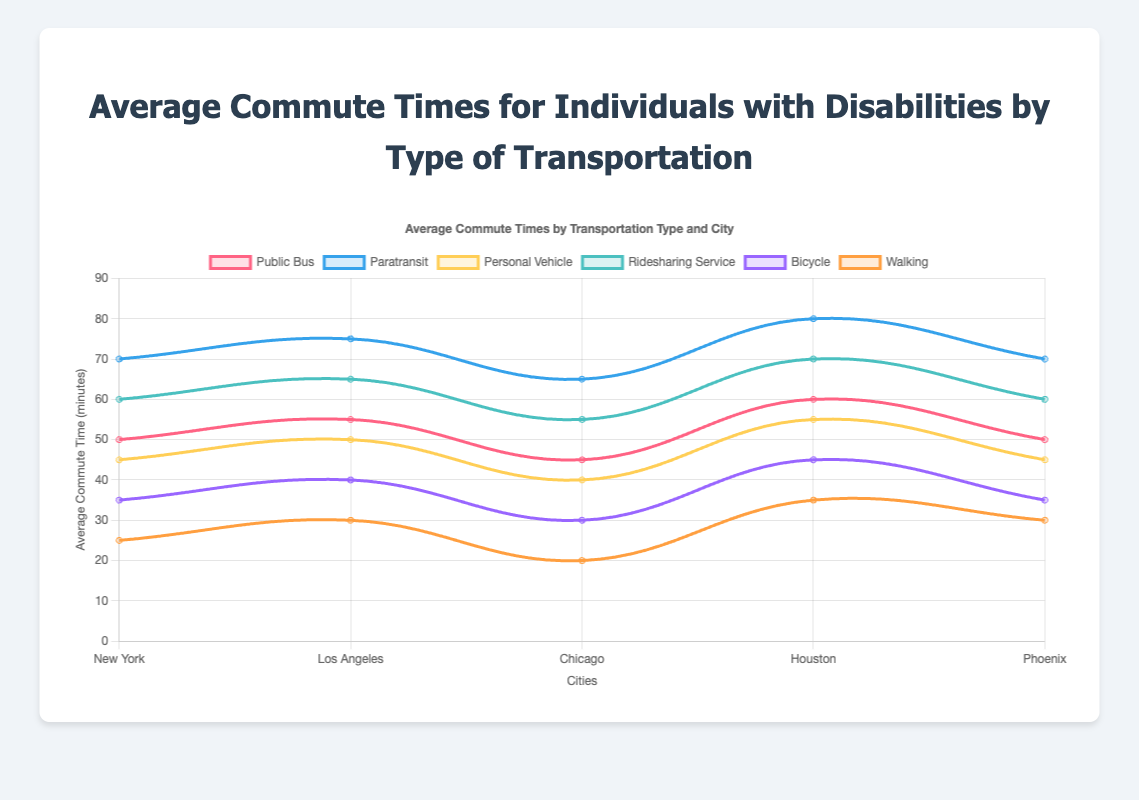What is the average commute time using a Public Bus in Chicago? The plot shows the average commute time for individuals with disabilities using various types of transportation in different cities. By locating "Public Bus" and finding the data point for "Chicago," we see that the value is 45 minutes.
Answer: 45 minutes Which city experiences the longest average commute time for Paratransit? Among the cities listed under Paratransit, identify the maximum value. The values are: New York (70), Los Angeles (75), Chicago (65), Houston (80), and Phoenix (70). The highest value is 80 minutes in Houston.
Answer: Houston How does the average commute time using Ridesharing Service in Phoenix compare to that in New York? Locate the data points for Ridesharing Service in both Phoenix and New York. Phoenix has a commute time of 60 minutes, and New York has a commute time of 60 minutes as well. Therefore, both times are equal.
Answer: They are equal What is the difference in average commute time between using a Bicycle and Walking in Los Angeles? Extract the commute times for Bicycle (40 minutes) and Walking (30 minutes) in Los Angeles. The difference is 40 - 30 = 10 minutes.
Answer: 10 minutes Which type of transportation has the shortest average commute time across all cities listed? By reviewing the lowest commute time for each type of transportation across all cities, identify the smallest value. The minimum values are: Public Bus (45), Paratransit (65), Personal Vehicle (40), Ridesharing Service (55), Bicycle (30), Walking (20). The shortest time is 20 minutes for Walking in Chicago.
Answer: Walking Calculate the average commute time for using a Personal Vehicle across all five cities. Sum the commute times for Personal Vehicle in the five cities: (New York 45) + (Los Angeles 50) + (Chicago 40) + (Houston 55) + (Phoenix 45). The total is 235 minutes. Divide by the number of cities (5): 235/5 = 47 minutes.
Answer: 47 minutes What is the color used to represent the Paratransit commute times? By observing the visual attributes of the plot, locate the line or markers representing Paratransit. Identify its color through visual inspection.
Answer: Blue In which city do individuals experience the shortest average commute time by Walking? Locate the commute times for Walking in all cities: New York (25), Los Angeles (30), Chicago (20), Houston (35), Phoenix (30). The shortest commute time is in Chicago at 20 minutes.
Answer: Chicago Compare the average commute times using a Public Bus and a Personal Vehicle in Houston. Which is shorter? Extract the data points for both Public Bus and Personal Vehicle in Houston. Public Bus is 60 minutes and Personal Vehicle is 55 minutes. Hence, traveling by Personal Vehicle is shorter.
Answer: Personal Vehicle What is the median commute time using Ridesharing Service across all cities? List the commute times for Ridesharing Service in all cities: 60, 65, 55, 70, and 60. Sorting these values: 55, 60, 60, 65, 70. The middle value (median) is 60 minutes.
Answer: 60 minutes 